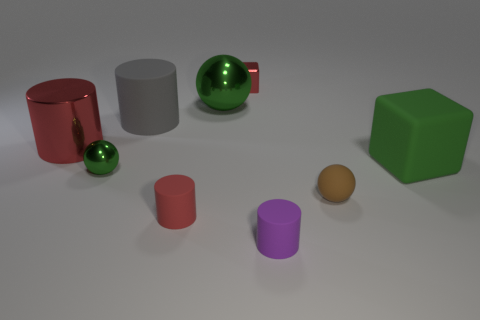Subtract 1 cylinders. How many cylinders are left? 3 Add 1 small gray matte cylinders. How many objects exist? 10 Subtract all cylinders. How many objects are left? 5 Add 8 large green things. How many large green things exist? 10 Subtract 0 cyan spheres. How many objects are left? 9 Subtract all green spheres. Subtract all tiny brown rubber objects. How many objects are left? 6 Add 4 green objects. How many green objects are left? 7 